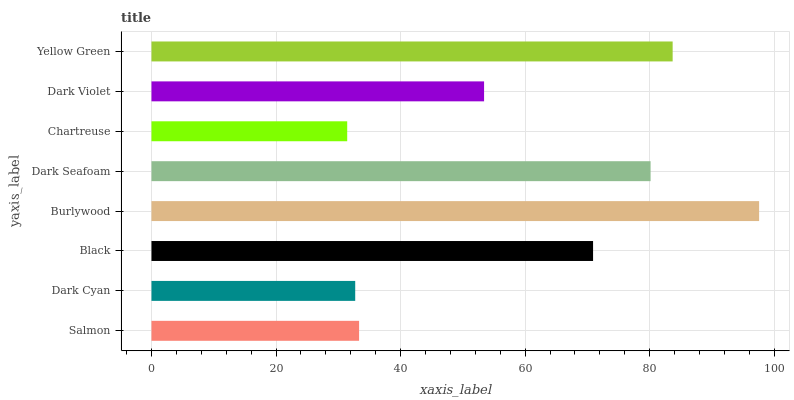Is Chartreuse the minimum?
Answer yes or no. Yes. Is Burlywood the maximum?
Answer yes or no. Yes. Is Dark Cyan the minimum?
Answer yes or no. No. Is Dark Cyan the maximum?
Answer yes or no. No. Is Salmon greater than Dark Cyan?
Answer yes or no. Yes. Is Dark Cyan less than Salmon?
Answer yes or no. Yes. Is Dark Cyan greater than Salmon?
Answer yes or no. No. Is Salmon less than Dark Cyan?
Answer yes or no. No. Is Black the high median?
Answer yes or no. Yes. Is Dark Violet the low median?
Answer yes or no. Yes. Is Dark Seafoam the high median?
Answer yes or no. No. Is Salmon the low median?
Answer yes or no. No. 